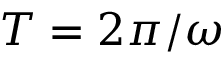<formula> <loc_0><loc_0><loc_500><loc_500>T = 2 \pi / \omega</formula> 